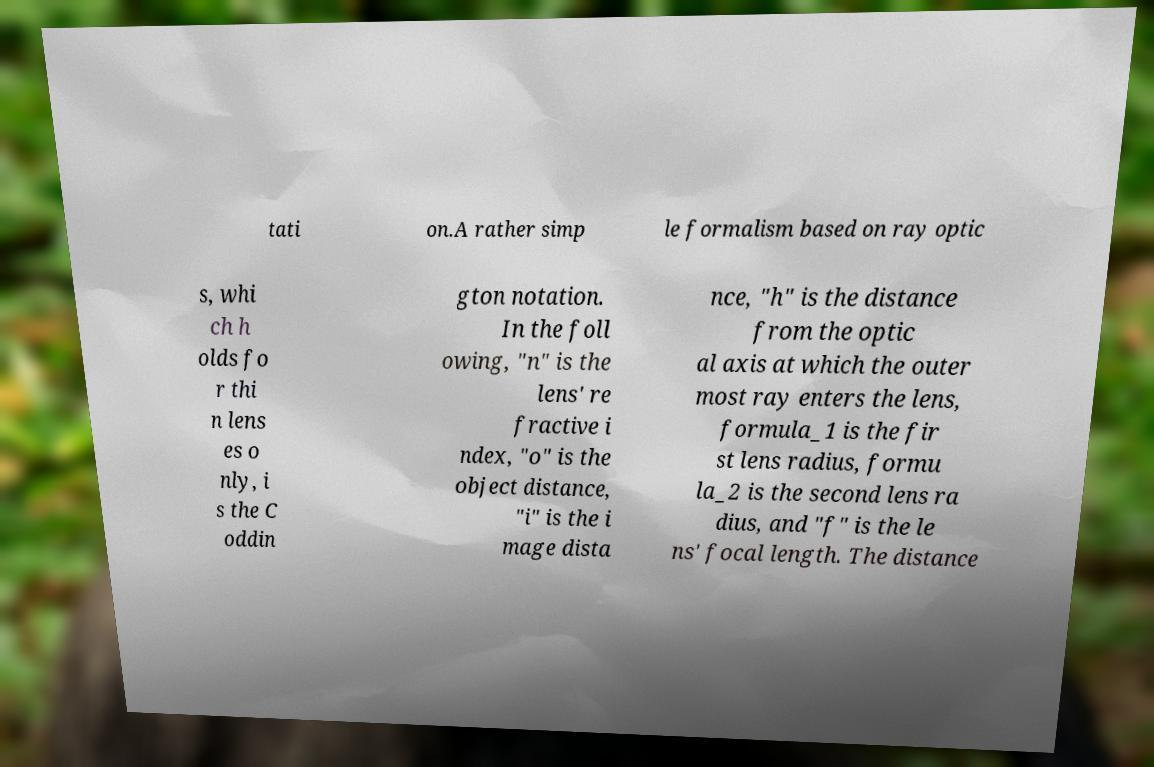Can you read and provide the text displayed in the image?This photo seems to have some interesting text. Can you extract and type it out for me? tati on.A rather simp le formalism based on ray optic s, whi ch h olds fo r thi n lens es o nly, i s the C oddin gton notation. In the foll owing, "n" is the lens' re fractive i ndex, "o" is the object distance, "i" is the i mage dista nce, "h" is the distance from the optic al axis at which the outer most ray enters the lens, formula_1 is the fir st lens radius, formu la_2 is the second lens ra dius, and "f" is the le ns' focal length. The distance 